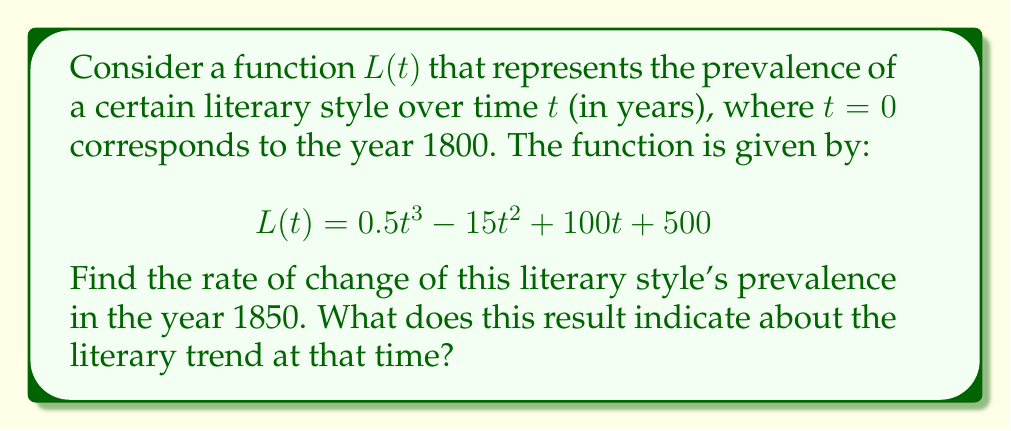Help me with this question. To solve this problem, we'll follow these steps:

1) First, we need to find the derivative of $L(t)$ with respect to $t$. This will give us the rate of change function:

   $$L'(t) = \frac{d}{dt}(0.5t^3 - 15t^2 + 100t + 500)$$
   $$L'(t) = 1.5t^2 - 30t + 100$$

2) Now, we need to find the value of $t$ that corresponds to the year 1850. Since $t=0$ is 1800, $t=50$ represents 1850.

3) We can now evaluate $L'(t)$ at $t=50$:

   $$L'(50) = 1.5(50)^2 - 30(50) + 100$$
   $$= 1.5(2500) - 1500 + 100$$
   $$= 3750 - 1500 + 100$$
   $$= 2350$$

4) Interpreting the result:
   The rate of change is positive and quite large, indicating that in 1850, this particular literary style was rapidly gaining popularity. The value 2350 means that the prevalence of this style was increasing at a rate of 2350 units per year at that time.
Answer: 2350 units/year, indicating rapid growth in popularity 